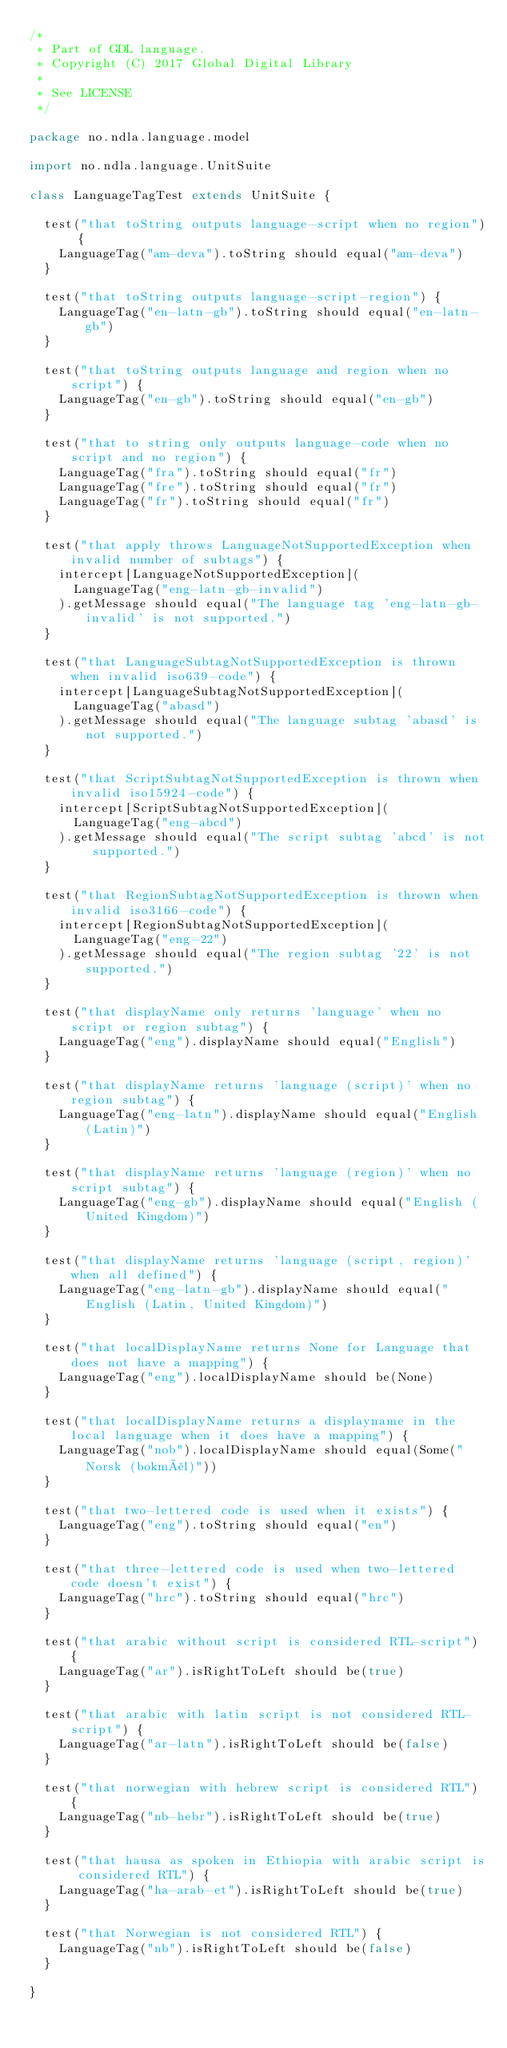<code> <loc_0><loc_0><loc_500><loc_500><_Scala_>/*
 * Part of GDL language.
 * Copyright (C) 2017 Global Digital Library
 *
 * See LICENSE
 */

package no.ndla.language.model

import no.ndla.language.UnitSuite

class LanguageTagTest extends UnitSuite {

  test("that toString outputs language-script when no region") {
    LanguageTag("am-deva").toString should equal("am-deva")
  }

  test("that toString outputs language-script-region") {
    LanguageTag("en-latn-gb").toString should equal("en-latn-gb")
  }

  test("that toString outputs language and region when no script") {
    LanguageTag("en-gb").toString should equal("en-gb")
  }

  test("that to string only outputs language-code when no script and no region") {
    LanguageTag("fra").toString should equal("fr")
    LanguageTag("fre").toString should equal("fr")
    LanguageTag("fr").toString should equal("fr")
  }

  test("that apply throws LanguageNotSupportedException when invalid number of subtags") {
    intercept[LanguageNotSupportedException](
      LanguageTag("eng-latn-gb-invalid")
    ).getMessage should equal("The language tag 'eng-latn-gb-invalid' is not supported.")
  }

  test("that LanguageSubtagNotSupportedException is thrown when invalid iso639-code") {
    intercept[LanguageSubtagNotSupportedException](
      LanguageTag("abasd")
    ).getMessage should equal("The language subtag 'abasd' is not supported.")
  }

  test("that ScriptSubtagNotSupportedException is thrown when invalid iso15924-code") {
    intercept[ScriptSubtagNotSupportedException](
      LanguageTag("eng-abcd")
    ).getMessage should equal("The script subtag 'abcd' is not supported.")
  }

  test("that RegionSubtagNotSupportedException is thrown when invalid iso3166-code") {
    intercept[RegionSubtagNotSupportedException](
      LanguageTag("eng-22")
    ).getMessage should equal("The region subtag '22' is not supported.")
  }

  test("that displayName only returns 'language' when no script or region subtag") {
    LanguageTag("eng").displayName should equal("English")
  }

  test("that displayName returns 'language (script)' when no region subtag") {
    LanguageTag("eng-latn").displayName should equal("English (Latin)")
  }

  test("that displayName returns 'language (region)' when no script subtag") {
    LanguageTag("eng-gb").displayName should equal("English (United Kingdom)")
  }

  test("that displayName returns 'language (script, region)' when all defined") {
    LanguageTag("eng-latn-gb").displayName should equal("English (Latin, United Kingdom)")
  }

  test("that localDisplayName returns None for Language that does not have a mapping") {
    LanguageTag("eng").localDisplayName should be(None)
  }

  test("that localDisplayName returns a displayname in the local language when it does have a mapping") {
    LanguageTag("nob").localDisplayName should equal(Some("Norsk (bokmål)"))
  }

  test("that two-lettered code is used when it exists") {
    LanguageTag("eng").toString should equal("en")
  }

  test("that three-lettered code is used when two-lettered code doesn't exist") {
    LanguageTag("hrc").toString should equal("hrc")
  }

  test("that arabic without script is considered RTL-script") {
    LanguageTag("ar").isRightToLeft should be(true)
  }

  test("that arabic with latin script is not considered RTL-script") {
    LanguageTag("ar-latn").isRightToLeft should be(false)
  }

  test("that norwegian with hebrew script is considered RTL") {
    LanguageTag("nb-hebr").isRightToLeft should be(true)
  }

  test("that hausa as spoken in Ethiopia with arabic script is considered RTL") {
    LanguageTag("ha-arab-et").isRightToLeft should be(true)
  }

  test("that Norwegian is not considered RTL") {
    LanguageTag("nb").isRightToLeft should be(false)
  }

}
</code> 